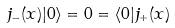<formula> <loc_0><loc_0><loc_500><loc_500>j _ { - } ( x ) | 0 \rangle = 0 = \langle 0 | j _ { + } ( x )</formula> 